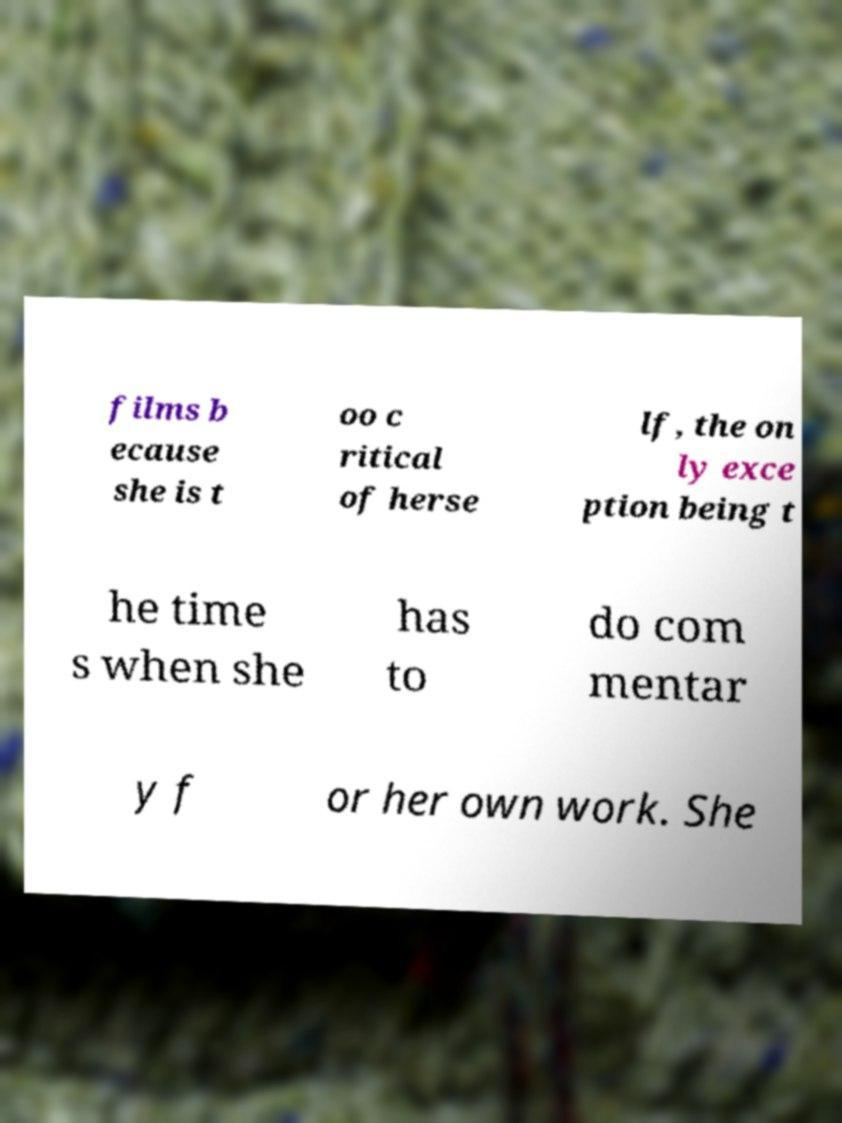There's text embedded in this image that I need extracted. Can you transcribe it verbatim? films b ecause she is t oo c ritical of herse lf, the on ly exce ption being t he time s when she has to do com mentar y f or her own work. She 